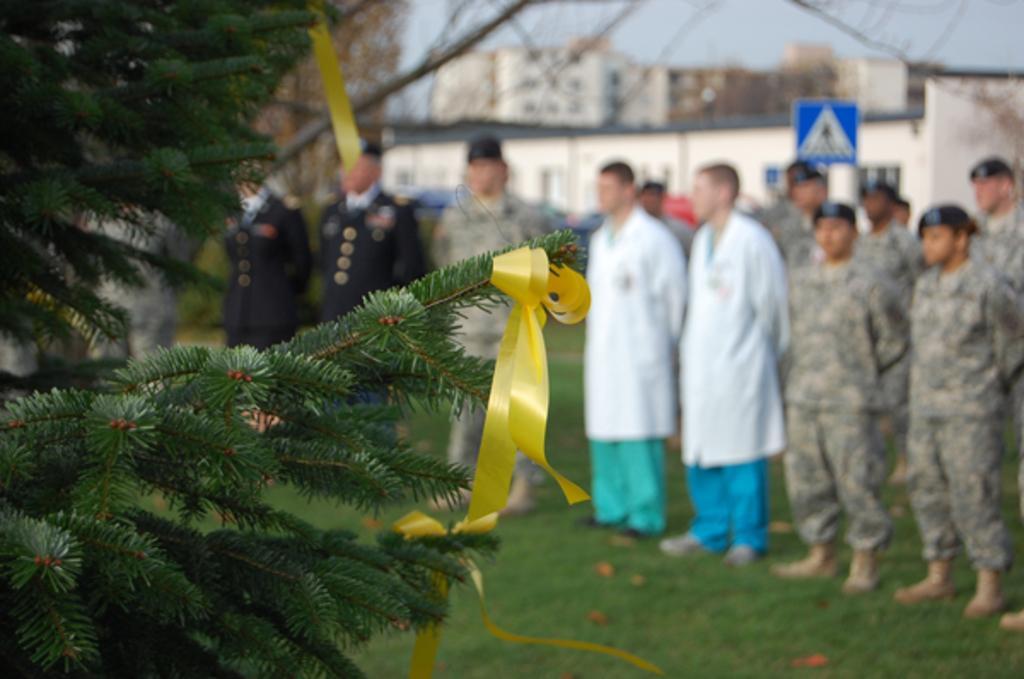Please provide a concise description of this image. In this image we can see a few people standing and also we can see a christmas tree with some ribbons, there are some buildings, windows and grass on the ground, also we can see a signboard and the sky. 